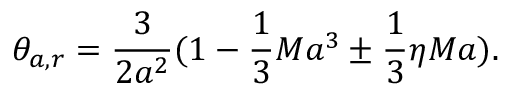Convert formula to latex. <formula><loc_0><loc_0><loc_500><loc_500>\theta _ { a , r } = \frac { 3 } { 2 a ^ { 2 } } ( 1 - \frac { 1 } { 3 } M a ^ { 3 } \pm \frac { 1 } { 3 } \eta M a ) .</formula> 